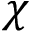<formula> <loc_0><loc_0><loc_500><loc_500>\chi</formula> 